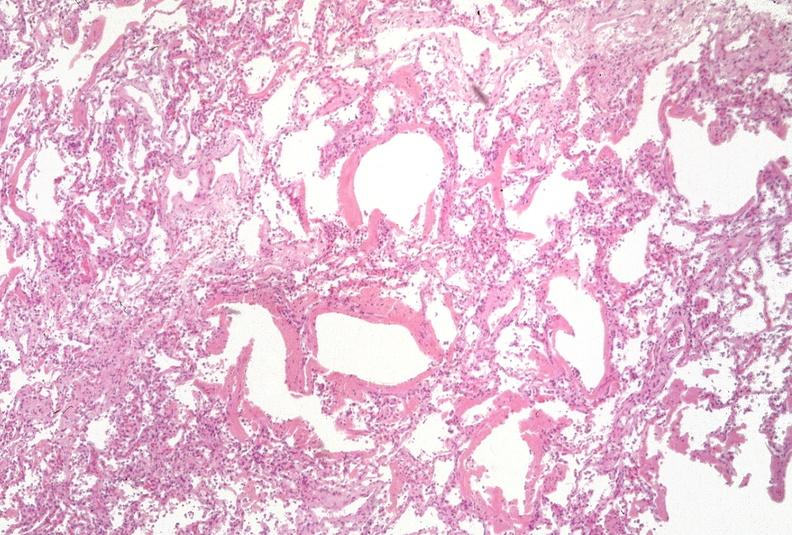does anencephaly and bilateral cleft palate show lung?
Answer the question using a single word or phrase. No 